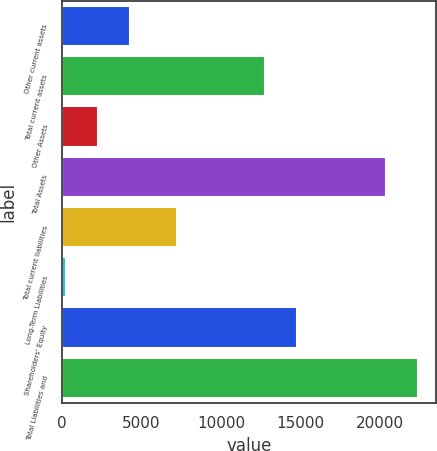<chart> <loc_0><loc_0><loc_500><loc_500><bar_chart><fcel>Other current assets<fcel>Total current assets<fcel>Other Assets<fcel>Total Assets<fcel>Total current liabilities<fcel>Long-Term Liabilities<fcel>Shareholders' Equity<fcel>Total Liabilities and<nl><fcel>4261.8<fcel>12771<fcel>2242.9<fcel>20413<fcel>7233<fcel>224<fcel>14789.9<fcel>22431.9<nl></chart> 